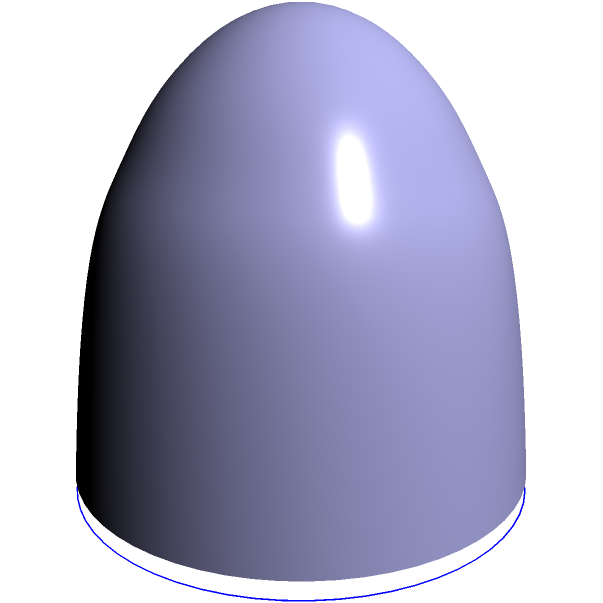The dome-shaped roof of our new church building is modeled by the equation $z = \sqrt{25 - x^2 - y^2}$, where $z$ represents the height above the circular base, and $x$ and $y$ are coordinates on the base. The base has a radius of 5 meters. Calculate the surface area of the dome roof using a double integral in polar coordinates. Round your answer to the nearest square meter. Let's approach this step-by-step:

1) The surface area of a function $z = f(x,y)$ over a region $R$ is given by the double integral:

   $$ A = \iint_R \sqrt{1 + \left(\frac{\partial z}{\partial x}\right)^2 + \left(\frac{\partial z}{\partial y}\right)^2} dA $$

2) First, let's find $\frac{\partial z}{\partial x}$ and $\frac{\partial z}{\partial y}$:
   
   $$ \frac{\partial z}{\partial x} = \frac{-x}{\sqrt{25 - x^2 - y^2}} $$
   $$ \frac{\partial z}{\partial y} = \frac{-y}{\sqrt{25 - x^2 - y^2}} $$

3) Substituting these into our surface area formula:

   $$ A = \iint_R \sqrt{1 + \frac{x^2}{25 - x^2 - y^2} + \frac{y^2}{25 - x^2 - y^2}} dA $$

4) Simplify under the square root:

   $$ A = \iint_R \sqrt{\frac{25}{25 - x^2 - y^2}} dA $$

5) Now, let's convert to polar coordinates. The region $R$ is a circle with radius 5, so in polar coordinates:
   $0 \leq r \leq 5$ and $0 \leq \theta \leq 2\pi$

   Also, $x^2 + y^2 = r^2$ in polar coordinates, so our integral becomes:

   $$ A = \int_0^{2\pi} \int_0^5 \sqrt{\frac{25}{25 - r^2}} r dr d\theta $$

6) The $r$ in the integrand comes from the conversion of $dA$ to polar coordinates.

7) Now, let's solve this integral:

   $$ A = 2\pi \int_0^5 \frac{5r}{\sqrt{25 - r^2}} dr $$

8) This integral can be solved by substitution. Let $u = 25 - r^2$, then $du = -2r dr$, or $-\frac{1}{2}du = r dr$

   $$ A = -5\pi \int_{25}^0 \frac{1}{\sqrt{u}} du $$

9) Evaluating this integral:

   $$ A = -5\pi [-2\sqrt{u}]_0^{25} = 10\pi(\sqrt{25} - 0) = 50\pi $$

10) Therefore, the surface area is $50\pi$ square meters. Rounding to the nearest square meter:

    $50\pi \approx 157$ square meters.
Answer: 157 square meters 